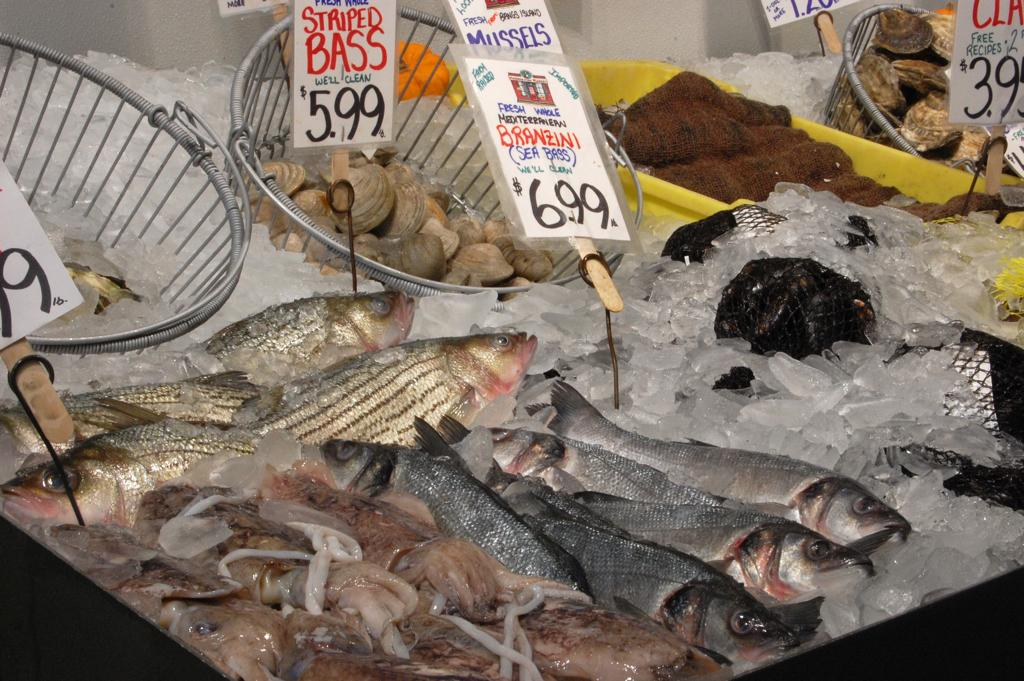What type of containers are in the image? There are containers in the image. What other object can be seen in the image besides the containers? There is a basket visible in the image. What information is provided about the items in the image? Price tags are visible in the image. What type of ice is present in the image? There are ice pieces in the image. What type of food is present in the image? Seafood is present in the image. What type of list is being used to organize the seafood in the image? There is no list present in the image; it only shows containers, a basket, price tags, ice pieces, and seafood. What role does the calculator play in the image? There is no calculator present in the image. 